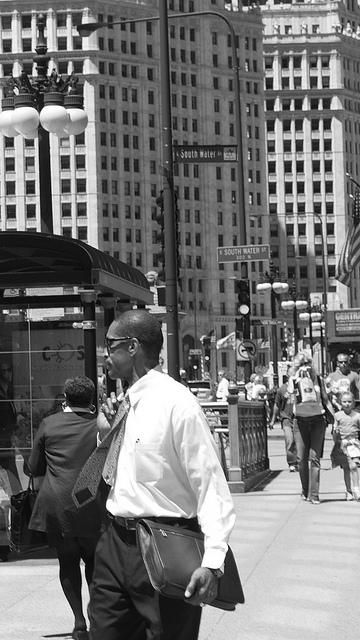What does the fenced in area behind the man lead to? Please explain your reasoning. subway. These are where the stairs are that go down to the train. 